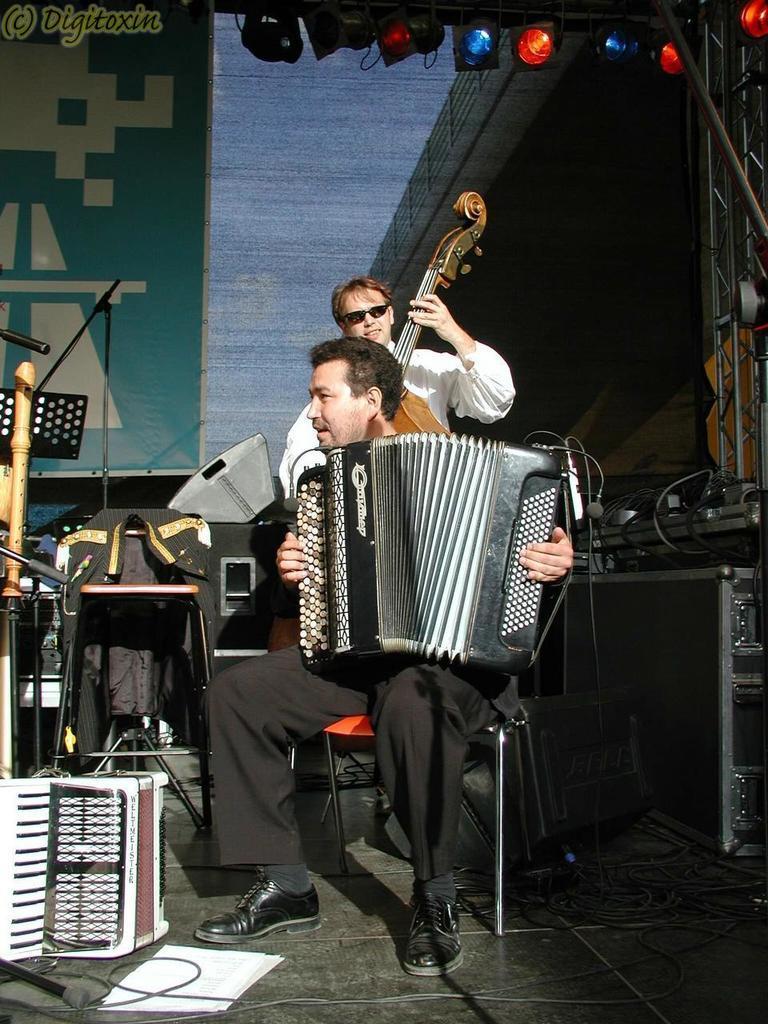Please provide a concise description of this image. In the image we can see two men wearing clothes and they are holding a musical instrument in their hands. Here we can see cable wires, papers and other electronic devices. Here we can see disco lights, floor and the poster. On the top left, we can see the watermark. 